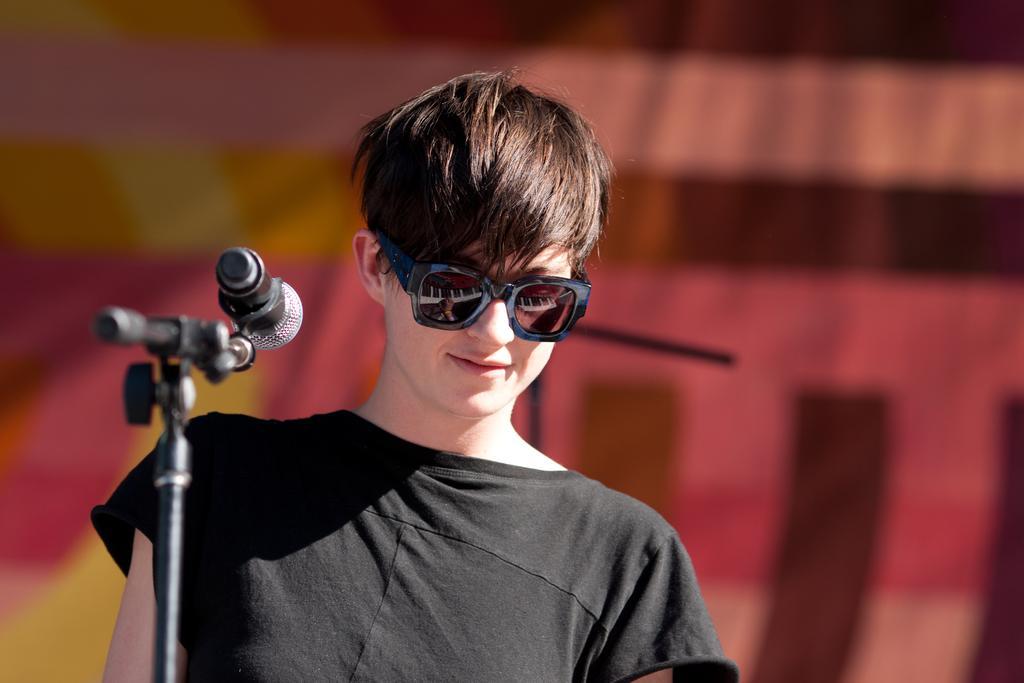Can you describe this image briefly? Here we can see a woman and she wore goggles to her eyes. On the left there is a mic on a stand. In the background the image is blur but we can see an object. 